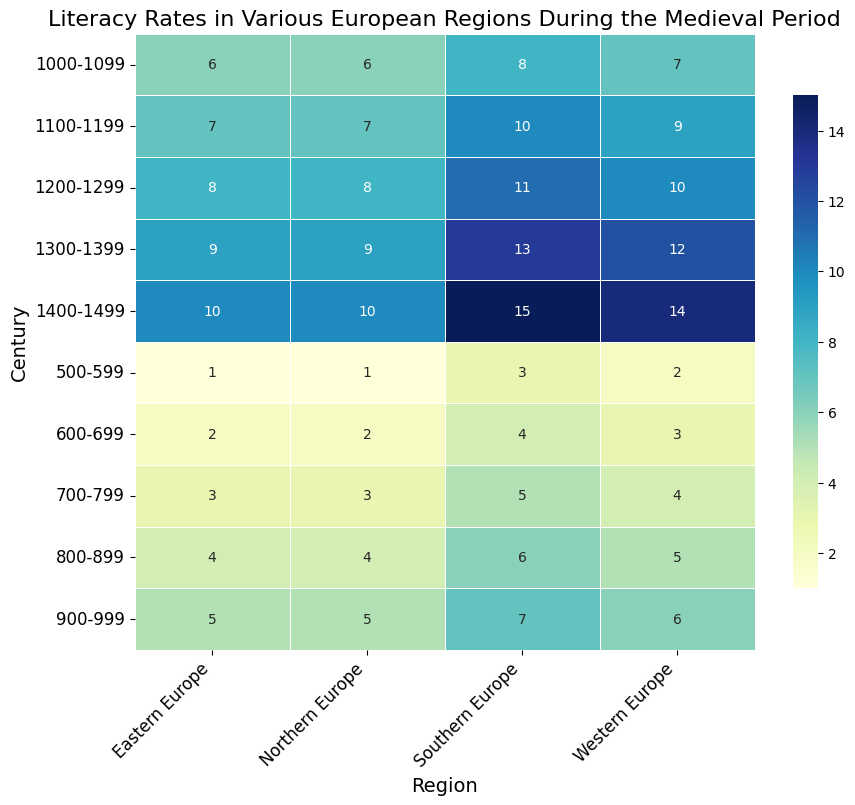What is the overall trend in literacy rates in Western Europe from the 6th century to the 15th century? The heatmap shows annotated literacy rates, and visually, the values for Western Europe increase consistently from 2 in the 6th century to 14 in the 15th century. This is a clear upward trend.
Answer: Increasing Which region had the highest literacy rate in the 1100-1199 century? The heatmap shows the literacy rates for each region in the 1100-1199 century. Southern Europe has the highest literacy rate of 10, compared to Western Europe (9), Eastern Europe (7), and Northern Europe (7).
Answer: Southern Europe Compare the literacy rates of Northern and Southern Europe in the 700-799 century. Which one is higher and by how much? In the 700-799 century, Northern Europe has a literacy rate of 3, while Southern Europe has a rate of 5. Subtracting the two values: 5 - 3 = 2, we find Southern Europe's literacy rate is 2 points higher.
Answer: Southern Europe by 2 What is the average literacy rate in Western Europe across all centuries displayed in the heatmap? Adding the literacy rates of Western Europe across all centuries and dividing by the number of centuries (10), we get (2+3+4+5+6+7+9+10+12+14)/10 = 7.2.
Answer: 7.2 Which region showed the least change in literacy rates from the 500-599 century to the 1400-1499 century? Comparing the literacy rates from 500-599 to 1400-1499, the differences are: Western Europe (14-2=12), Eastern Europe (10-1=9), Northern Europe (10-1=9), Southern Europe (15-3=12). Thus, Eastern and Northern Europe both showed the least change with 9 points.
Answer: Eastern Europe and Northern Europe In which century did Eastern Europe first achieve a literacy rate of 5? Reviewing the annotated values for Eastern Europe in the heatmap, the first instance of a literacy rate of 5 occurs in the 900-999 century.
Answer: 900-999 Which region had the lowest literacy rate in the 1300-1399 century and what was it? The heatmap indicates that Eastern Europe had the lowest literacy rate in the 1300-1399 century, with a rate of 9.
Answer: Eastern Europe, 9 How many centuries did Northern Europe maintain a literacy rate of 6 or higher? Checking each century from the heatmap, Northern Europe's literacy rates were 6 or higher in the 1000-1099, 1100-1199, 1200-1299, 1300-1399, and 1400-1499 centuries, totaling 5 centuries.
Answer: 5 Compare the overall trends in literacy rates between Eastern and Southern Europe. Which had a more pronounced increase? From the heatmap, Eastern Europe went from 1 to 10 (increase of 9), while Southern Europe went from 3 to 15 (increase of 12). Southern Europe had a more pronounced increase.
Answer: Southern Europe What is the difference in literacy rates between Western and Eastern Europe in the 1400-1499 century? The heatmap shows Western Europe had a literacy rate of 14 and Eastern Europe had a rate of 10. The difference is 14 - 10 = 4.
Answer: 4 